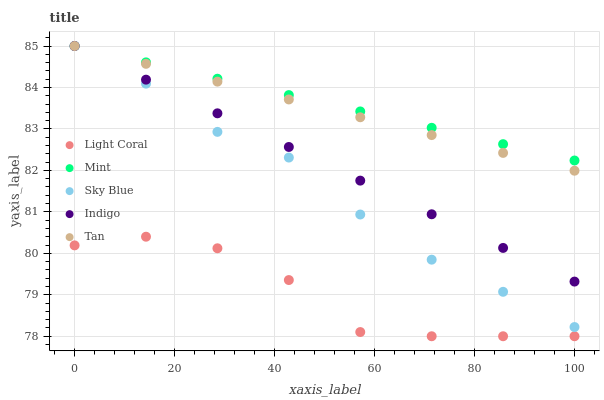Does Light Coral have the minimum area under the curve?
Answer yes or no. Yes. Does Mint have the maximum area under the curve?
Answer yes or no. Yes. Does Sky Blue have the minimum area under the curve?
Answer yes or no. No. Does Sky Blue have the maximum area under the curve?
Answer yes or no. No. Is Mint the smoothest?
Answer yes or no. Yes. Is Light Coral the roughest?
Answer yes or no. Yes. Is Sky Blue the smoothest?
Answer yes or no. No. Is Sky Blue the roughest?
Answer yes or no. No. Does Light Coral have the lowest value?
Answer yes or no. Yes. Does Sky Blue have the lowest value?
Answer yes or no. No. Does Indigo have the highest value?
Answer yes or no. Yes. Is Light Coral less than Mint?
Answer yes or no. Yes. Is Indigo greater than Light Coral?
Answer yes or no. Yes. Does Sky Blue intersect Indigo?
Answer yes or no. Yes. Is Sky Blue less than Indigo?
Answer yes or no. No. Is Sky Blue greater than Indigo?
Answer yes or no. No. Does Light Coral intersect Mint?
Answer yes or no. No. 